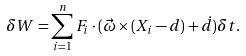<formula> <loc_0><loc_0><loc_500><loc_500>\delta W = \sum _ { i = 1 } ^ { n } F _ { i } \cdot ( { \vec { \omega } } \times ( X _ { i } - d ) + { \dot { d } } ) \delta t .</formula> 